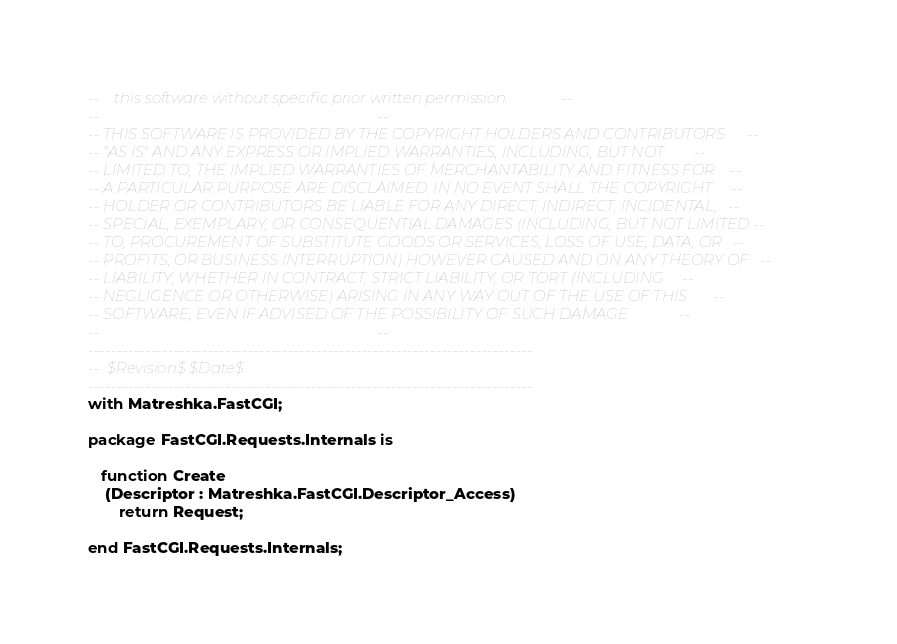<code> <loc_0><loc_0><loc_500><loc_500><_Ada_>--    this software without specific prior written permission.              --
--                                                                          --
-- THIS SOFTWARE IS PROVIDED BY THE COPYRIGHT HOLDERS AND CONTRIBUTORS      --
-- "AS IS" AND ANY EXPRESS OR IMPLIED WARRANTIES, INCLUDING, BUT NOT        --
-- LIMITED TO, THE IMPLIED WARRANTIES OF MERCHANTABILITY AND FITNESS FOR    --
-- A PARTICULAR PURPOSE ARE DISCLAIMED. IN NO EVENT SHALL THE COPYRIGHT     --
-- HOLDER OR CONTRIBUTORS BE LIABLE FOR ANY DIRECT, INDIRECT, INCIDENTAL,   --
-- SPECIAL, EXEMPLARY, OR CONSEQUENTIAL DAMAGES (INCLUDING, BUT NOT LIMITED --
-- TO, PROCUREMENT OF SUBSTITUTE GOODS OR SERVICES; LOSS OF USE, DATA, OR   --
-- PROFITS; OR BUSINESS INTERRUPTION) HOWEVER CAUSED AND ON ANY THEORY OF   --
-- LIABILITY, WHETHER IN CONTRACT, STRICT LIABILITY, OR TORT (INCLUDING     --
-- NEGLIGENCE OR OTHERWISE) ARISING IN ANY WAY OUT OF THE USE OF THIS       --
-- SOFTWARE, EVEN IF ADVISED OF THE POSSIBILITY OF SUCH DAMAGE.             --
--                                                                          --
------------------------------------------------------------------------------
--  $Revision$ $Date$
------------------------------------------------------------------------------
with Matreshka.FastCGI;

package FastCGI.Requests.Internals is

   function Create
    (Descriptor : Matreshka.FastCGI.Descriptor_Access)
       return Request;

end FastCGI.Requests.Internals;
</code> 